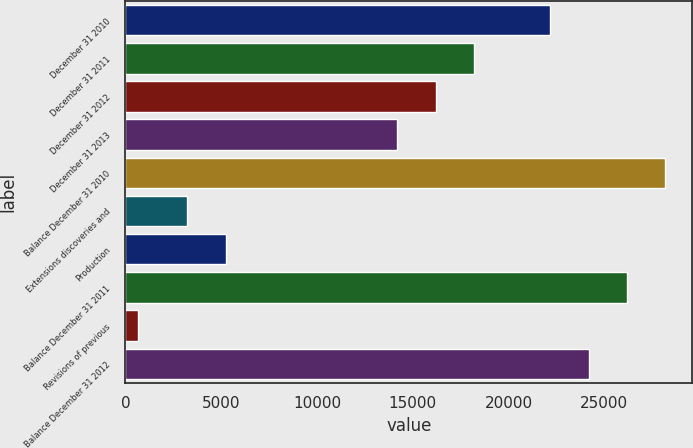Convert chart to OTSL. <chart><loc_0><loc_0><loc_500><loc_500><bar_chart><fcel>December 31 2010<fcel>December 31 2011<fcel>December 31 2012<fcel>December 31 2013<fcel>Balance December 31 2010<fcel>Extensions discoveries and<fcel>Production<fcel>Balance December 31 2011<fcel>Revisions of previous<fcel>Balance December 31 2012<nl><fcel>22184.6<fcel>18189.8<fcel>16192.4<fcel>14195<fcel>28176.8<fcel>3230<fcel>5227.4<fcel>26179.4<fcel>671<fcel>24182<nl></chart> 